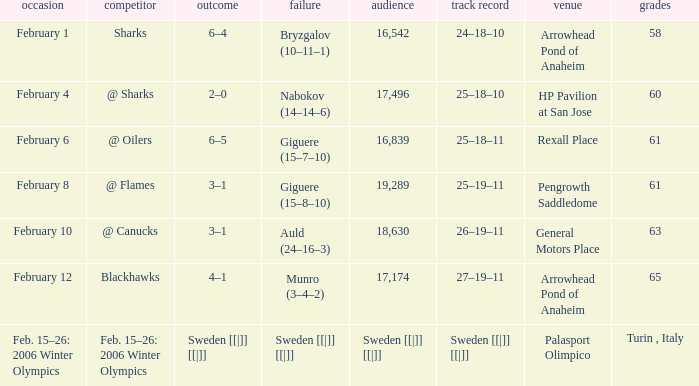What is the points when the score was 3–1, and record was 25–19–11? 61.0. 